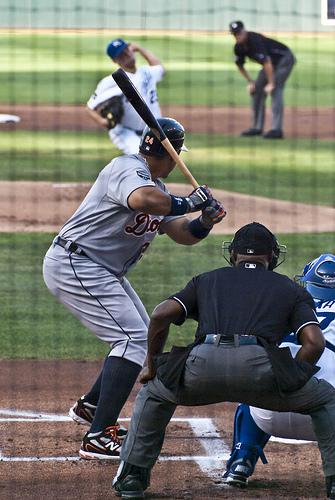Question: why is the umpire squatting down?
Choices:
A. To see the pitch.
B. To make correct calls.
C. So the pitcher will throw the ball.
D. For safety reasons.
Answer with the letter. Answer: A Question: what game are the men playing?
Choices:
A. Football.
B. Golf.
C. Basketball.
D. Baseball.
Answer with the letter. Answer: D Question: where is the batter standing?
Choices:
A. Batters box.
B. At home plate.
C. On the field.
D. Inside the lines.
Answer with the letter. Answer: A Question: what brand cleats is the catcher wearing?
Choices:
A. Nike.
B. Rebox.
C. Adidas.
D. Jordans.
Answer with the letter. Answer: A Question: what hand is the pitcher throwing with?
Choices:
A. Right.
B. Prosthetic.
C. Other.
D. Left.
Answer with the letter. Answer: D 